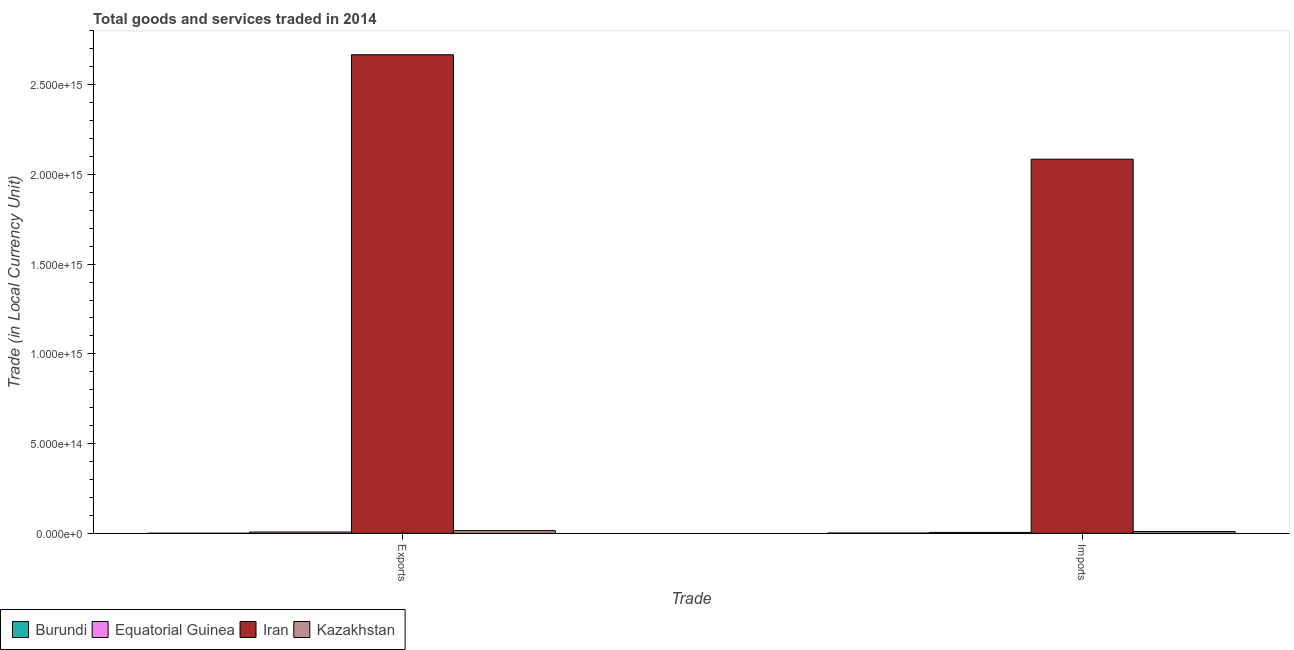How many groups of bars are there?
Make the answer very short. 2. Are the number of bars per tick equal to the number of legend labels?
Your response must be concise. Yes. How many bars are there on the 1st tick from the right?
Offer a terse response. 4. What is the label of the 2nd group of bars from the left?
Your answer should be compact. Imports. What is the export of goods and services in Burundi?
Offer a terse response. 3.72e+11. Across all countries, what is the maximum export of goods and services?
Your response must be concise. 2.67e+15. Across all countries, what is the minimum imports of goods and services?
Make the answer very short. 1.60e+12. In which country was the export of goods and services maximum?
Make the answer very short. Iran. In which country was the imports of goods and services minimum?
Your answer should be very brief. Burundi. What is the total imports of goods and services in the graph?
Offer a very short reply. 2.10e+15. What is the difference between the imports of goods and services in Burundi and that in Equatorial Guinea?
Make the answer very short. -3.55e+12. What is the difference between the export of goods and services in Iran and the imports of goods and services in Kazakhstan?
Offer a terse response. 2.66e+15. What is the average imports of goods and services per country?
Your answer should be very brief. 5.25e+14. What is the difference between the imports of goods and services and export of goods and services in Iran?
Make the answer very short. -5.82e+14. In how many countries, is the imports of goods and services greater than 2500000000000000 LCU?
Keep it short and to the point. 0. What is the ratio of the imports of goods and services in Kazakhstan to that in Burundi?
Provide a short and direct response. 6.3. Is the export of goods and services in Burundi less than that in Kazakhstan?
Provide a short and direct response. Yes. In how many countries, is the export of goods and services greater than the average export of goods and services taken over all countries?
Offer a terse response. 1. What does the 3rd bar from the left in Imports represents?
Offer a terse response. Iran. What does the 3rd bar from the right in Imports represents?
Provide a short and direct response. Equatorial Guinea. Are all the bars in the graph horizontal?
Your response must be concise. No. What is the difference between two consecutive major ticks on the Y-axis?
Offer a terse response. 5.00e+14. Are the values on the major ticks of Y-axis written in scientific E-notation?
Make the answer very short. Yes. Does the graph contain grids?
Offer a terse response. No. How many legend labels are there?
Make the answer very short. 4. What is the title of the graph?
Make the answer very short. Total goods and services traded in 2014. Does "Australia" appear as one of the legend labels in the graph?
Your answer should be very brief. No. What is the label or title of the X-axis?
Offer a very short reply. Trade. What is the label or title of the Y-axis?
Provide a succinct answer. Trade (in Local Currency Unit). What is the Trade (in Local Currency Unit) in Burundi in Exports?
Offer a terse response. 3.72e+11. What is the Trade (in Local Currency Unit) of Equatorial Guinea in Exports?
Provide a short and direct response. 7.34e+12. What is the Trade (in Local Currency Unit) of Iran in Exports?
Your answer should be compact. 2.67e+15. What is the Trade (in Local Currency Unit) of Kazakhstan in Exports?
Your answer should be very brief. 1.53e+13. What is the Trade (in Local Currency Unit) of Burundi in Imports?
Provide a succinct answer. 1.60e+12. What is the Trade (in Local Currency Unit) in Equatorial Guinea in Imports?
Ensure brevity in your answer.  5.16e+12. What is the Trade (in Local Currency Unit) in Iran in Imports?
Ensure brevity in your answer.  2.08e+15. What is the Trade (in Local Currency Unit) of Kazakhstan in Imports?
Give a very brief answer. 1.01e+13. Across all Trade, what is the maximum Trade (in Local Currency Unit) of Burundi?
Provide a short and direct response. 1.60e+12. Across all Trade, what is the maximum Trade (in Local Currency Unit) of Equatorial Guinea?
Your answer should be very brief. 7.34e+12. Across all Trade, what is the maximum Trade (in Local Currency Unit) in Iran?
Your response must be concise. 2.67e+15. Across all Trade, what is the maximum Trade (in Local Currency Unit) in Kazakhstan?
Give a very brief answer. 1.53e+13. Across all Trade, what is the minimum Trade (in Local Currency Unit) of Burundi?
Keep it short and to the point. 3.72e+11. Across all Trade, what is the minimum Trade (in Local Currency Unit) of Equatorial Guinea?
Your answer should be very brief. 5.16e+12. Across all Trade, what is the minimum Trade (in Local Currency Unit) of Iran?
Give a very brief answer. 2.08e+15. Across all Trade, what is the minimum Trade (in Local Currency Unit) in Kazakhstan?
Ensure brevity in your answer.  1.01e+13. What is the total Trade (in Local Currency Unit) in Burundi in the graph?
Ensure brevity in your answer.  1.98e+12. What is the total Trade (in Local Currency Unit) in Equatorial Guinea in the graph?
Your answer should be very brief. 1.25e+13. What is the total Trade (in Local Currency Unit) in Iran in the graph?
Your answer should be compact. 4.75e+15. What is the total Trade (in Local Currency Unit) of Kazakhstan in the graph?
Your response must be concise. 2.54e+13. What is the difference between the Trade (in Local Currency Unit) in Burundi in Exports and that in Imports?
Ensure brevity in your answer.  -1.23e+12. What is the difference between the Trade (in Local Currency Unit) of Equatorial Guinea in Exports and that in Imports?
Offer a very short reply. 2.19e+12. What is the difference between the Trade (in Local Currency Unit) in Iran in Exports and that in Imports?
Your answer should be compact. 5.82e+14. What is the difference between the Trade (in Local Currency Unit) in Kazakhstan in Exports and that in Imports?
Your answer should be compact. 5.17e+12. What is the difference between the Trade (in Local Currency Unit) in Burundi in Exports and the Trade (in Local Currency Unit) in Equatorial Guinea in Imports?
Your answer should be compact. -4.78e+12. What is the difference between the Trade (in Local Currency Unit) of Burundi in Exports and the Trade (in Local Currency Unit) of Iran in Imports?
Provide a short and direct response. -2.08e+15. What is the difference between the Trade (in Local Currency Unit) in Burundi in Exports and the Trade (in Local Currency Unit) in Kazakhstan in Imports?
Your answer should be compact. -9.73e+12. What is the difference between the Trade (in Local Currency Unit) of Equatorial Guinea in Exports and the Trade (in Local Currency Unit) of Iran in Imports?
Offer a terse response. -2.08e+15. What is the difference between the Trade (in Local Currency Unit) in Equatorial Guinea in Exports and the Trade (in Local Currency Unit) in Kazakhstan in Imports?
Your answer should be compact. -2.76e+12. What is the difference between the Trade (in Local Currency Unit) in Iran in Exports and the Trade (in Local Currency Unit) in Kazakhstan in Imports?
Provide a succinct answer. 2.66e+15. What is the average Trade (in Local Currency Unit) in Burundi per Trade?
Offer a terse response. 9.88e+11. What is the average Trade (in Local Currency Unit) in Equatorial Guinea per Trade?
Your answer should be very brief. 6.25e+12. What is the average Trade (in Local Currency Unit) in Iran per Trade?
Offer a very short reply. 2.38e+15. What is the average Trade (in Local Currency Unit) in Kazakhstan per Trade?
Keep it short and to the point. 1.27e+13. What is the difference between the Trade (in Local Currency Unit) in Burundi and Trade (in Local Currency Unit) in Equatorial Guinea in Exports?
Make the answer very short. -6.97e+12. What is the difference between the Trade (in Local Currency Unit) of Burundi and Trade (in Local Currency Unit) of Iran in Exports?
Ensure brevity in your answer.  -2.67e+15. What is the difference between the Trade (in Local Currency Unit) in Burundi and Trade (in Local Currency Unit) in Kazakhstan in Exports?
Give a very brief answer. -1.49e+13. What is the difference between the Trade (in Local Currency Unit) of Equatorial Guinea and Trade (in Local Currency Unit) of Iran in Exports?
Keep it short and to the point. -2.66e+15. What is the difference between the Trade (in Local Currency Unit) of Equatorial Guinea and Trade (in Local Currency Unit) of Kazakhstan in Exports?
Offer a terse response. -7.93e+12. What is the difference between the Trade (in Local Currency Unit) in Iran and Trade (in Local Currency Unit) in Kazakhstan in Exports?
Your answer should be very brief. 2.65e+15. What is the difference between the Trade (in Local Currency Unit) in Burundi and Trade (in Local Currency Unit) in Equatorial Guinea in Imports?
Provide a short and direct response. -3.55e+12. What is the difference between the Trade (in Local Currency Unit) in Burundi and Trade (in Local Currency Unit) in Iran in Imports?
Give a very brief answer. -2.08e+15. What is the difference between the Trade (in Local Currency Unit) of Burundi and Trade (in Local Currency Unit) of Kazakhstan in Imports?
Offer a very short reply. -8.50e+12. What is the difference between the Trade (in Local Currency Unit) in Equatorial Guinea and Trade (in Local Currency Unit) in Iran in Imports?
Provide a succinct answer. -2.08e+15. What is the difference between the Trade (in Local Currency Unit) of Equatorial Guinea and Trade (in Local Currency Unit) of Kazakhstan in Imports?
Your answer should be very brief. -4.95e+12. What is the difference between the Trade (in Local Currency Unit) in Iran and Trade (in Local Currency Unit) in Kazakhstan in Imports?
Ensure brevity in your answer.  2.07e+15. What is the ratio of the Trade (in Local Currency Unit) of Burundi in Exports to that in Imports?
Give a very brief answer. 0.23. What is the ratio of the Trade (in Local Currency Unit) in Equatorial Guinea in Exports to that in Imports?
Offer a terse response. 1.42. What is the ratio of the Trade (in Local Currency Unit) in Iran in Exports to that in Imports?
Ensure brevity in your answer.  1.28. What is the ratio of the Trade (in Local Currency Unit) in Kazakhstan in Exports to that in Imports?
Ensure brevity in your answer.  1.51. What is the difference between the highest and the second highest Trade (in Local Currency Unit) of Burundi?
Offer a very short reply. 1.23e+12. What is the difference between the highest and the second highest Trade (in Local Currency Unit) of Equatorial Guinea?
Ensure brevity in your answer.  2.19e+12. What is the difference between the highest and the second highest Trade (in Local Currency Unit) in Iran?
Offer a very short reply. 5.82e+14. What is the difference between the highest and the second highest Trade (in Local Currency Unit) of Kazakhstan?
Offer a very short reply. 5.17e+12. What is the difference between the highest and the lowest Trade (in Local Currency Unit) of Burundi?
Give a very brief answer. 1.23e+12. What is the difference between the highest and the lowest Trade (in Local Currency Unit) of Equatorial Guinea?
Keep it short and to the point. 2.19e+12. What is the difference between the highest and the lowest Trade (in Local Currency Unit) in Iran?
Give a very brief answer. 5.82e+14. What is the difference between the highest and the lowest Trade (in Local Currency Unit) of Kazakhstan?
Your answer should be compact. 5.17e+12. 